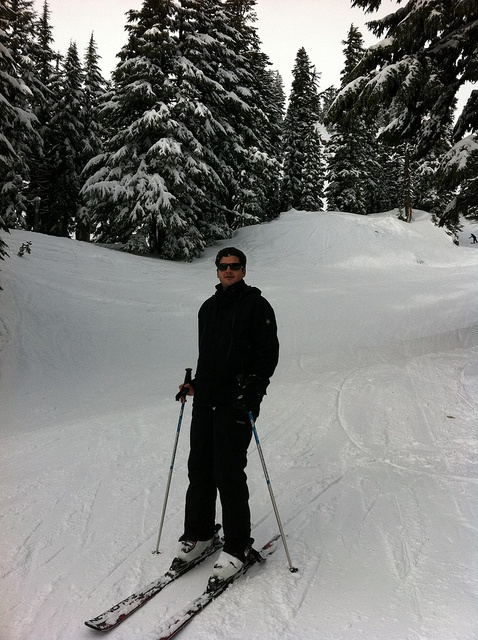Describe the objects in this image and their specific colors. I can see people in black, darkgray, gray, and maroon tones and skis in black, darkgray, and gray tones in this image. 